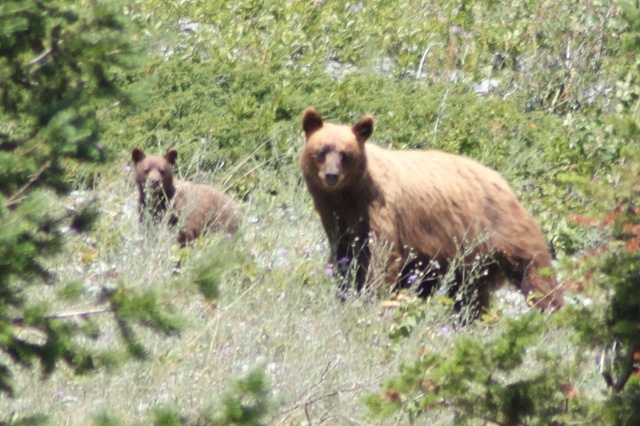Describe the objects in this image and their specific colors. I can see bear in darkgreen, black, gray, tan, and beige tones and bear in darkgreen, darkgray, gray, and tan tones in this image. 